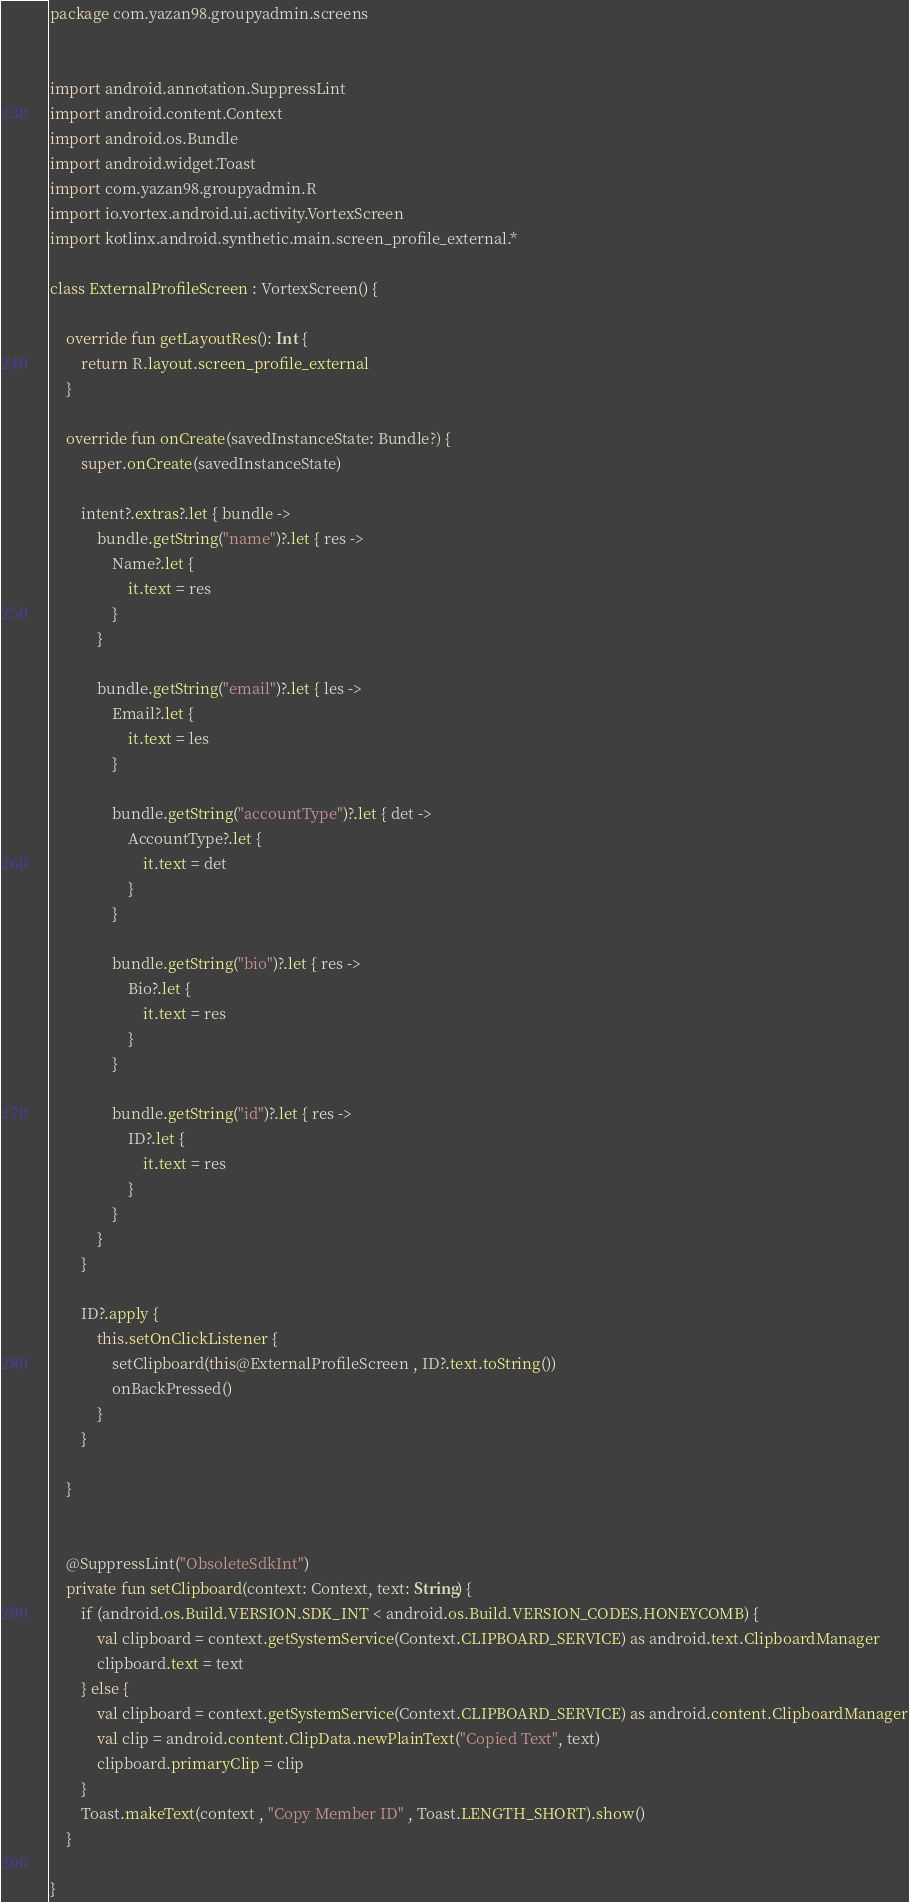Convert code to text. <code><loc_0><loc_0><loc_500><loc_500><_Kotlin_>package com.yazan98.groupyadmin.screens


import android.annotation.SuppressLint
import android.content.Context
import android.os.Bundle
import android.widget.Toast
import com.yazan98.groupyadmin.R
import io.vortex.android.ui.activity.VortexScreen
import kotlinx.android.synthetic.main.screen_profile_external.*

class ExternalProfileScreen : VortexScreen() {

    override fun getLayoutRes(): Int {
        return R.layout.screen_profile_external
    }

    override fun onCreate(savedInstanceState: Bundle?) {
        super.onCreate(savedInstanceState)

        intent?.extras?.let { bundle ->
            bundle.getString("name")?.let { res ->
                Name?.let {
                    it.text = res
                }
            }

            bundle.getString("email")?.let { les ->
                Email?.let {
                    it.text = les
                }

                bundle.getString("accountType")?.let { det ->
                    AccountType?.let {
                        it.text = det
                    }
                }

                bundle.getString("bio")?.let { res ->
                    Bio?.let {
                        it.text = res
                    }
                }

                bundle.getString("id")?.let { res ->
                    ID?.let {
                        it.text = res
                    }
                }
            }
        }

        ID?.apply {
            this.setOnClickListener {
                setClipboard(this@ExternalProfileScreen , ID?.text.toString())
                onBackPressed()
            }
        }

    }


    @SuppressLint("ObsoleteSdkInt")
    private fun setClipboard(context: Context, text: String) {
        if (android.os.Build.VERSION.SDK_INT < android.os.Build.VERSION_CODES.HONEYCOMB) {
            val clipboard = context.getSystemService(Context.CLIPBOARD_SERVICE) as android.text.ClipboardManager
            clipboard.text = text
        } else {
            val clipboard = context.getSystemService(Context.CLIPBOARD_SERVICE) as android.content.ClipboardManager
            val clip = android.content.ClipData.newPlainText("Copied Text", text)
            clipboard.primaryClip = clip
        }
        Toast.makeText(context , "Copy Member ID" , Toast.LENGTH_SHORT).show()
    }

}</code> 